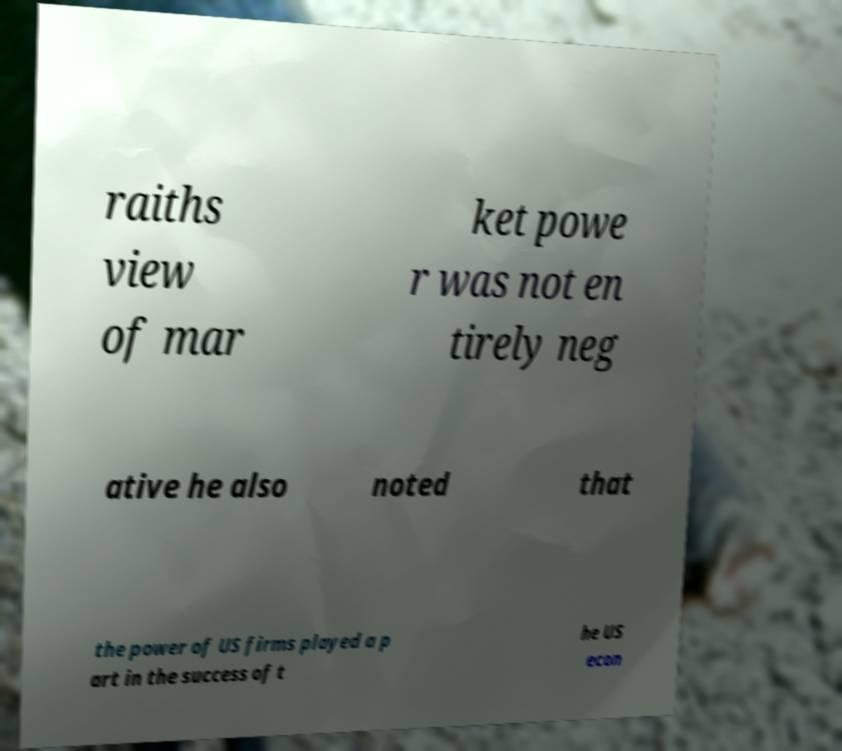Could you assist in decoding the text presented in this image and type it out clearly? raiths view of mar ket powe r was not en tirely neg ative he also noted that the power of US firms played a p art in the success of t he US econ 